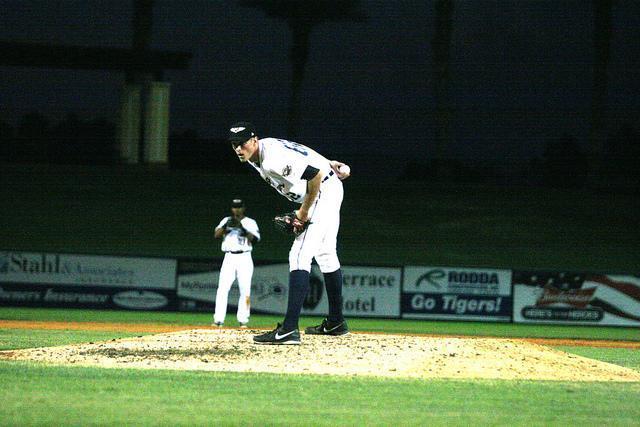How many people are there?
Give a very brief answer. 2. 